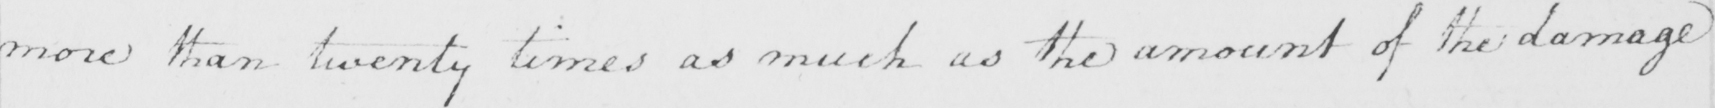Please provide the text content of this handwritten line. more than twenty times as much as the amount of the damage 